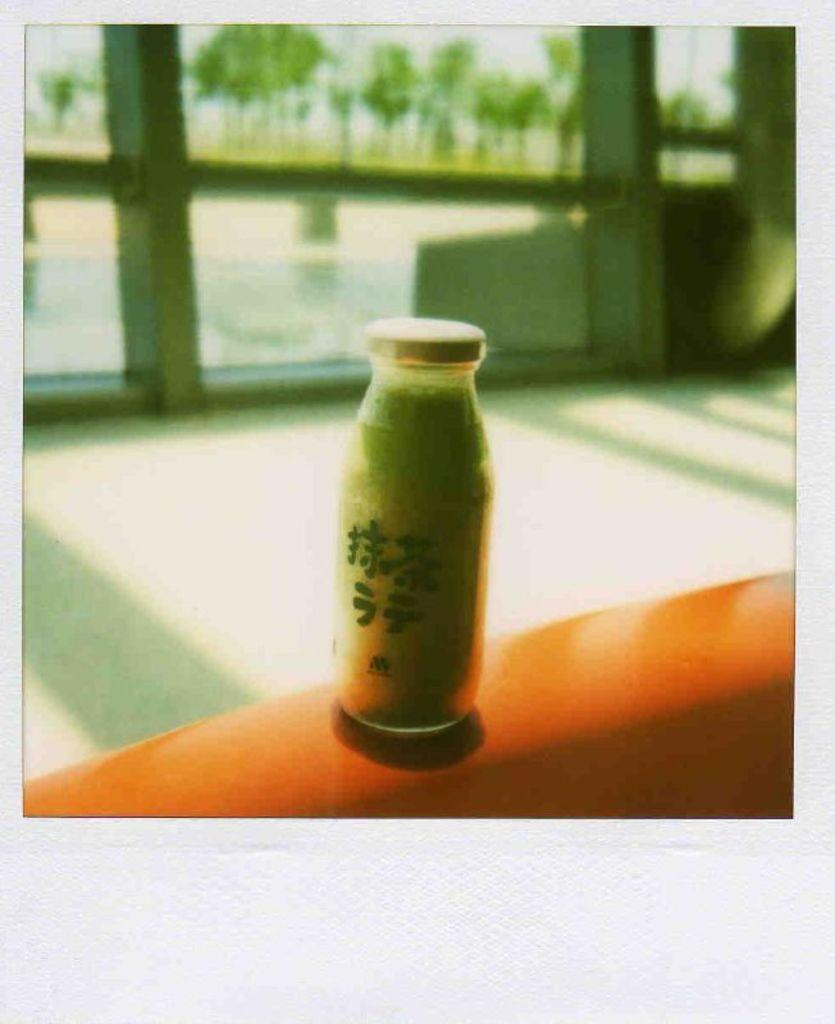Please provide a concise description of this image. in this image there is a bottle which is kept on a wall which is in orange color ,In the background there is a glass window which is in white color 